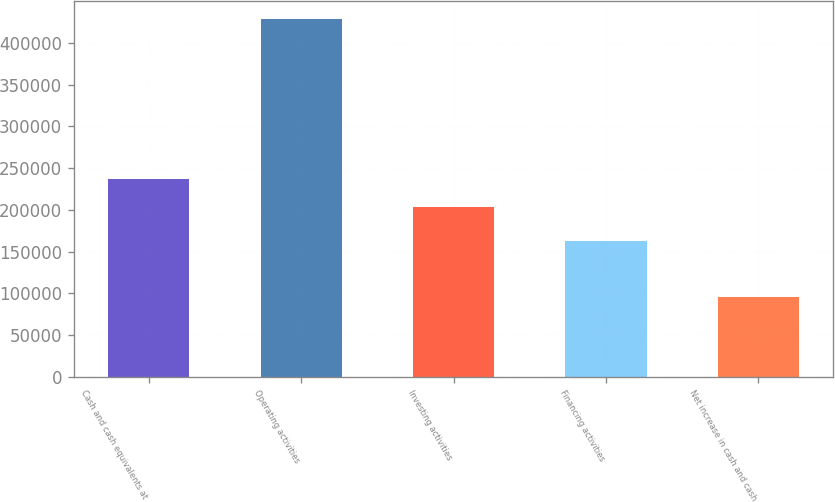Convert chart to OTSL. <chart><loc_0><loc_0><loc_500><loc_500><bar_chart><fcel>Cash and cash equivalents at<fcel>Operating activities<fcel>Investing activities<fcel>Financing activities<fcel>Net increase in cash and cash<nl><fcel>237153<fcel>428265<fcel>203930<fcel>162483<fcel>96037<nl></chart> 